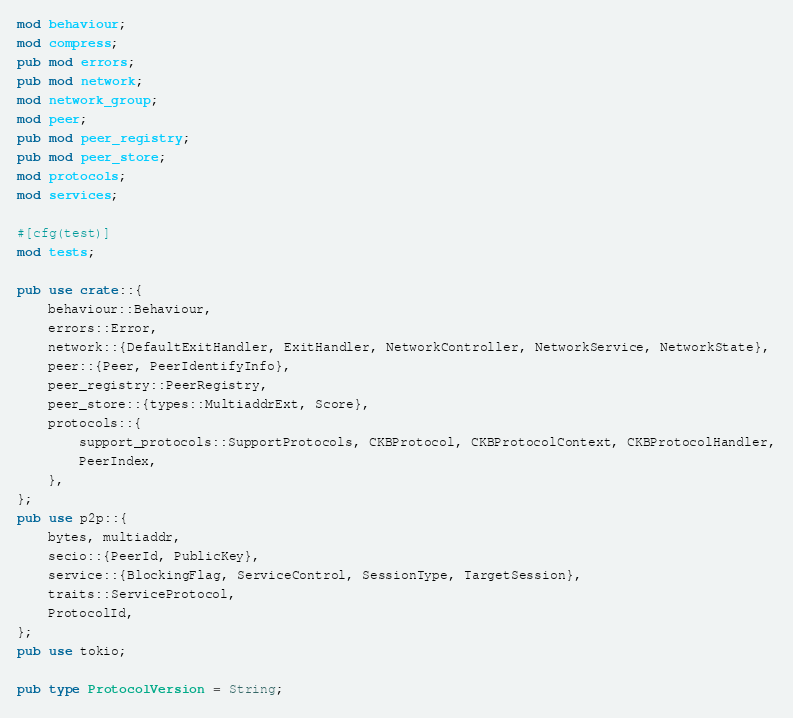Convert code to text. <code><loc_0><loc_0><loc_500><loc_500><_Rust_>mod behaviour;
mod compress;
pub mod errors;
pub mod network;
mod network_group;
mod peer;
pub mod peer_registry;
pub mod peer_store;
mod protocols;
mod services;

#[cfg(test)]
mod tests;

pub use crate::{
    behaviour::Behaviour,
    errors::Error,
    network::{DefaultExitHandler, ExitHandler, NetworkController, NetworkService, NetworkState},
    peer::{Peer, PeerIdentifyInfo},
    peer_registry::PeerRegistry,
    peer_store::{types::MultiaddrExt, Score},
    protocols::{
        support_protocols::SupportProtocols, CKBProtocol, CKBProtocolContext, CKBProtocolHandler,
        PeerIndex,
    },
};
pub use p2p::{
    bytes, multiaddr,
    secio::{PeerId, PublicKey},
    service::{BlockingFlag, ServiceControl, SessionType, TargetSession},
    traits::ServiceProtocol,
    ProtocolId,
};
pub use tokio;

pub type ProtocolVersion = String;
</code> 